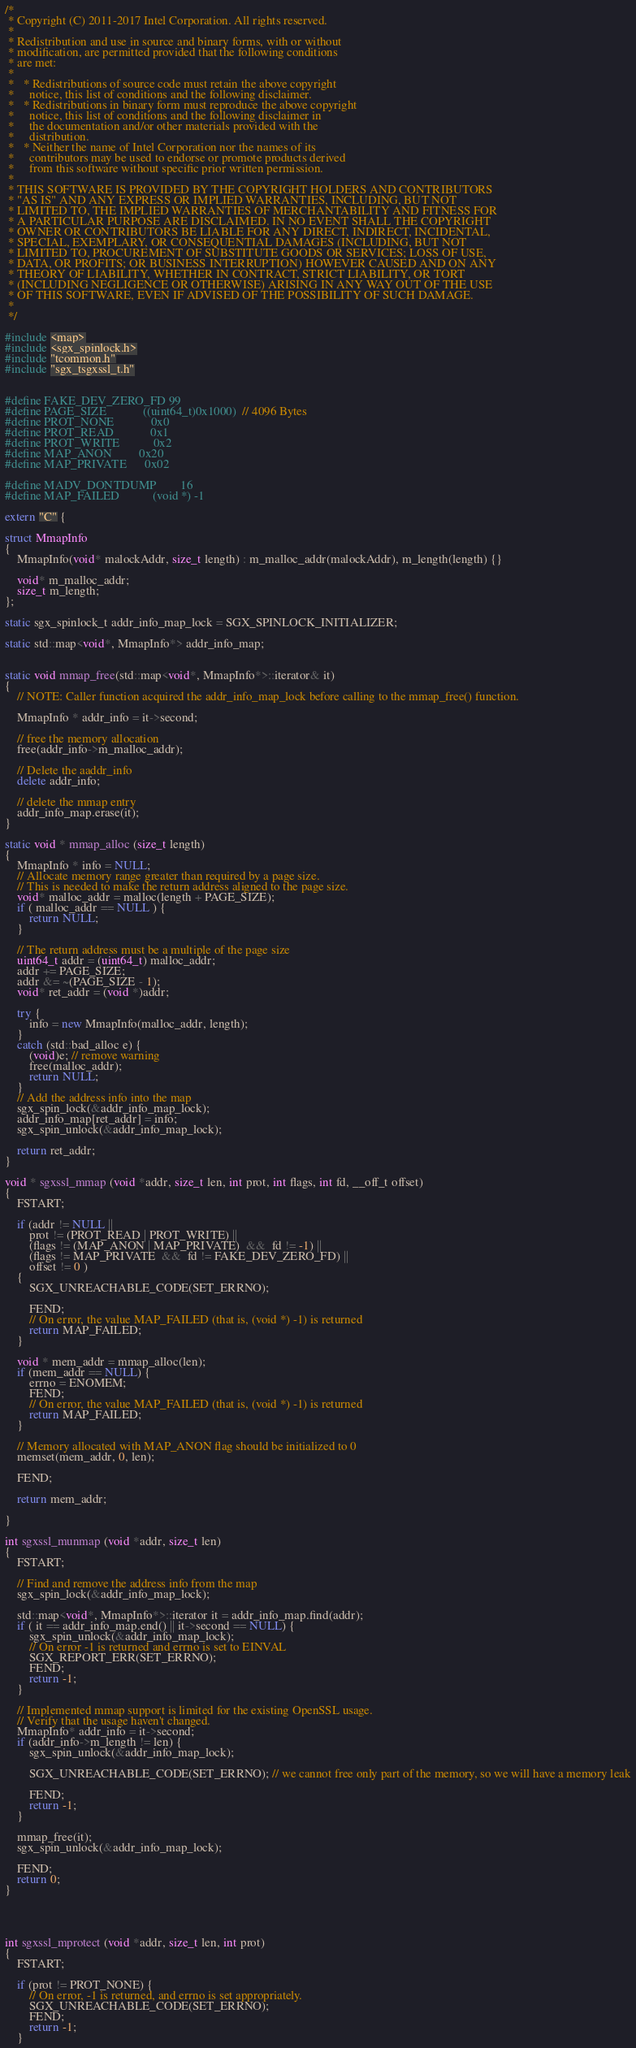Convert code to text. <code><loc_0><loc_0><loc_500><loc_500><_C++_>/*
 * Copyright (C) 2011-2017 Intel Corporation. All rights reserved.
 *
 * Redistribution and use in source and binary forms, with or without
 * modification, are permitted provided that the following conditions
 * are met:
 *
 *   * Redistributions of source code must retain the above copyright
 *     notice, this list of conditions and the following disclaimer.
 *   * Redistributions in binary form must reproduce the above copyright
 *     notice, this list of conditions and the following disclaimer in
 *     the documentation and/or other materials provided with the
 *     distribution.
 *   * Neither the name of Intel Corporation nor the names of its
 *     contributors may be used to endorse or promote products derived
 *     from this software without specific prior written permission.
 *
 * THIS SOFTWARE IS PROVIDED BY THE COPYRIGHT HOLDERS AND CONTRIBUTORS
 * "AS IS" AND ANY EXPRESS OR IMPLIED WARRANTIES, INCLUDING, BUT NOT
 * LIMITED TO, THE IMPLIED WARRANTIES OF MERCHANTABILITY AND FITNESS FOR
 * A PARTICULAR PURPOSE ARE DISCLAIMED. IN NO EVENT SHALL THE COPYRIGHT
 * OWNER OR CONTRIBUTORS BE LIABLE FOR ANY DIRECT, INDIRECT, INCIDENTAL,
 * SPECIAL, EXEMPLARY, OR CONSEQUENTIAL DAMAGES (INCLUDING, BUT NOT
 * LIMITED TO, PROCUREMENT OF SUBSTITUTE GOODS OR SERVICES; LOSS OF USE,
 * DATA, OR PROFITS; OR BUSINESS INTERRUPTION) HOWEVER CAUSED AND ON ANY
 * THEORY OF LIABILITY, WHETHER IN CONTRACT, STRICT LIABILITY, OR TORT
 * (INCLUDING NEGLIGENCE OR OTHERWISE) ARISING IN ANY WAY OUT OF THE USE
 * OF THIS SOFTWARE, EVEN IF ADVISED OF THE POSSIBILITY OF SUCH DAMAGE.
 *
 */

#include <map>
#include <sgx_spinlock.h>
#include "tcommon.h"
#include "sgx_tsgxssl_t.h"


#define FAKE_DEV_ZERO_FD	99
#define PAGE_SIZE 			((uint64_t)0x1000) 	// 4096 Bytes
#define PROT_NONE			0x0
#define PROT_READ			0x1
#define PROT_WRITE			0x2
#define MAP_ANON			0x20
#define MAP_PRIVATE 		0x02

#define MADV_DONTDUMP		16
#define MAP_FAILED			(void *) -1

extern "C" {

struct MmapInfo
{
	MmapInfo(void* malockAddr, size_t length) : m_malloc_addr(malockAddr), m_length(length) {}

	void* m_malloc_addr;
	size_t m_length;
};

static sgx_spinlock_t addr_info_map_lock = SGX_SPINLOCK_INITIALIZER;

static std::map<void*, MmapInfo*> addr_info_map;


static void mmap_free(std::map<void*, MmapInfo*>::iterator& it)
{
	// NOTE: Caller function acquired the addr_info_map_lock before calling to the mmap_free() function.

	MmapInfo * addr_info = it->second;

	// free the memory allocation
	free(addr_info->m_malloc_addr);

	// Delete the aaddr_info
	delete addr_info;

	// delete the mmap entry
	addr_info_map.erase(it);
}

static void * mmap_alloc (size_t length)
{
	MmapInfo * info = NULL;
	// Allocate memory range greater than required by a page size.
	// This is needed to make the return address aligned to the page size.
	void* malloc_addr = malloc(length + PAGE_SIZE);
	if ( malloc_addr == NULL ) {
		return NULL;
	}

	// The return address must be a multiple of the page size
	uint64_t addr = (uint64_t) malloc_addr;
	addr += PAGE_SIZE;
	addr &= ~(PAGE_SIZE - 1);
	void* ret_addr = (void *)addr;

	try {
		info = new MmapInfo(malloc_addr, length);
	}
	catch (std::bad_alloc e) {
		(void)e; // remove warning
		free(malloc_addr);
		return NULL;
	}
	// Add the address info into the map
	sgx_spin_lock(&addr_info_map_lock);
	addr_info_map[ret_addr] = info;
	sgx_spin_unlock(&addr_info_map_lock);

	return ret_addr;
}

void * sgxssl_mmap (void *addr, size_t len, int prot, int flags, int fd, __off_t offset)
{
	FSTART;

	if (addr != NULL ||
		prot != (PROT_READ | PROT_WRITE) ||
		(flags != (MAP_ANON | MAP_PRIVATE)  &&  fd != -1) ||
		(flags != MAP_PRIVATE  &&  fd != FAKE_DEV_ZERO_FD) ||
		offset != 0 )
	{
		SGX_UNREACHABLE_CODE(SET_ERRNO);

		FEND;
		// On error, the value MAP_FAILED (that is, (void *) -1) is returned
		return MAP_FAILED;
	}

	void * mem_addr = mmap_alloc(len);
	if (mem_addr == NULL) {
		errno = ENOMEM;
		FEND;
		// On error, the value MAP_FAILED (that is, (void *) -1) is returned
		return MAP_FAILED;
	}

	// Memory allocated with MAP_ANON flag should be initialized to 0
	memset(mem_addr, 0, len);

	FEND;

	return mem_addr;

}

int sgxssl_munmap (void *addr, size_t len)
{
	FSTART;

	// Find and remove the address info from the map
	sgx_spin_lock(&addr_info_map_lock);

	std::map<void*, MmapInfo*>::iterator it = addr_info_map.find(addr);
	if ( it == addr_info_map.end() || it->second == NULL) {
		sgx_spin_unlock(&addr_info_map_lock);
		// On error -1 is returned and errno is set to EINVAL
		SGX_REPORT_ERR(SET_ERRNO);
		FEND;
		return -1;
	}

	// Implemented mmap support is limited for the existing OpenSSL usage.
	// Verify that the usage haven't changed.
	MmapInfo* addr_info = it->second;
	if (addr_info->m_length != len) {
		sgx_spin_unlock(&addr_info_map_lock);
		
		SGX_UNREACHABLE_CODE(SET_ERRNO); // we cannot free only part of the memory, so we will have a memory leak
		
		FEND;
		return -1;
	}

	mmap_free(it);
	sgx_spin_unlock(&addr_info_map_lock);

	FEND;
	return 0;
}




int sgxssl_mprotect (void *addr, size_t len, int prot)
{
	FSTART;

	if (prot != PROT_NONE) {
		// On error, -1 is returned, and errno is set appropriately.
		SGX_UNREACHABLE_CODE(SET_ERRNO);
		FEND;
		return -1;
	}
</code> 